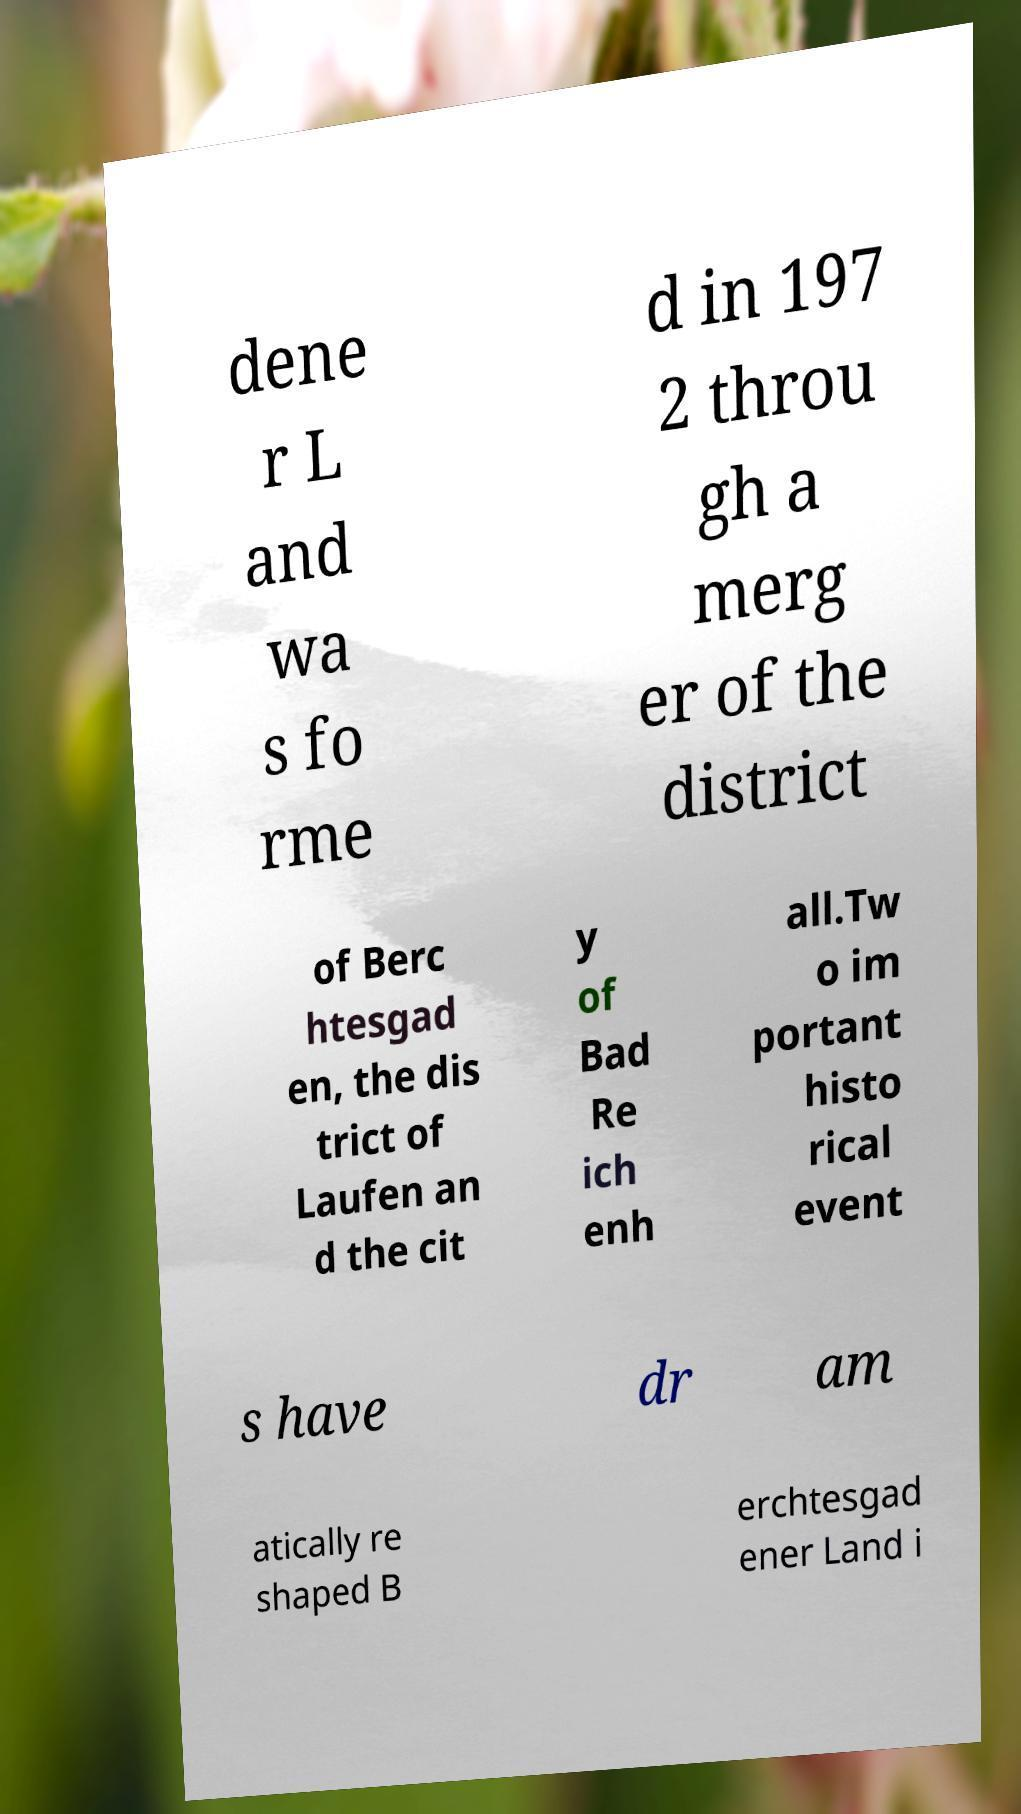Could you assist in decoding the text presented in this image and type it out clearly? dene r L and wa s fo rme d in 197 2 throu gh a merg er of the district of Berc htesgad en, the dis trict of Laufen an d the cit y of Bad Re ich enh all.Tw o im portant histo rical event s have dr am atically re shaped B erchtesgad ener Land i 